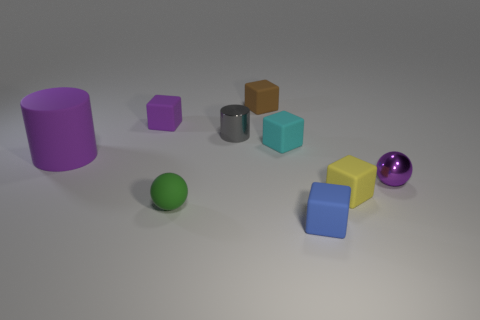There is a brown block that is made of the same material as the cyan cube; what size is it?
Provide a short and direct response. Small. Is there anything else that is the same color as the shiny cylinder?
Your response must be concise. No. There is a tiny shiny object that is to the right of the blue rubber thing; does it have the same color as the rubber cube on the left side of the green matte ball?
Ensure brevity in your answer.  Yes. What color is the cube that is in front of the yellow thing?
Your answer should be very brief. Blue. Do the matte object in front of the green sphere and the big purple rubber thing have the same size?
Give a very brief answer. No. Is the number of matte cylinders less than the number of cyan cylinders?
Give a very brief answer. No. There is a tiny metal thing that is the same color as the large rubber object; what is its shape?
Your answer should be very brief. Sphere. There is a gray cylinder; what number of tiny purple balls are behind it?
Keep it short and to the point. 0. Do the tiny yellow thing and the large object have the same shape?
Offer a terse response. No. What number of cubes are both in front of the purple ball and behind the tiny blue thing?
Your response must be concise. 1. 